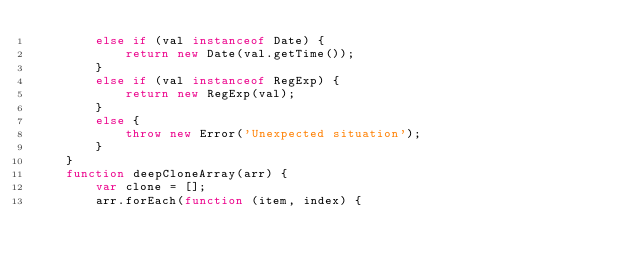Convert code to text. <code><loc_0><loc_0><loc_500><loc_500><_JavaScript_>        else if (val instanceof Date) {
            return new Date(val.getTime());
        }
        else if (val instanceof RegExp) {
            return new RegExp(val);
        }
        else {
            throw new Error('Unexpected situation');
        }
    }
    function deepCloneArray(arr) {
        var clone = [];
        arr.forEach(function (item, index) {</code> 